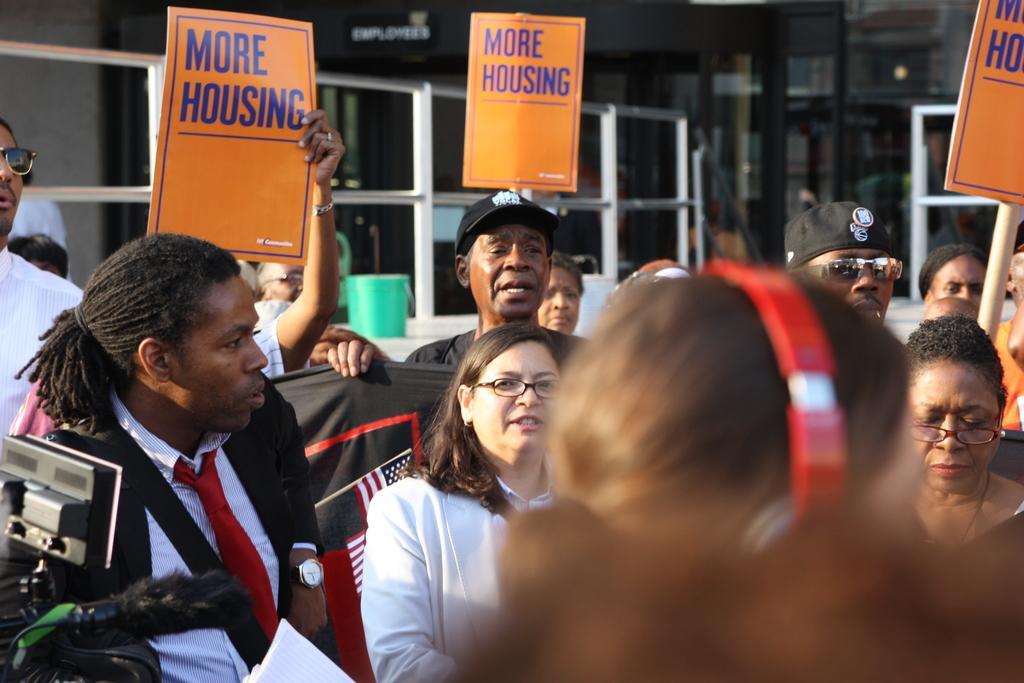Please provide a concise description of this image. In this image I can see the group of people with different color dresses. I can see the few people are holding the boards and banners. I can see few people are wearing the caps and goggles and one person with the headset. To the left I can see the camera. In the background I can see the green color bucket and the building. 